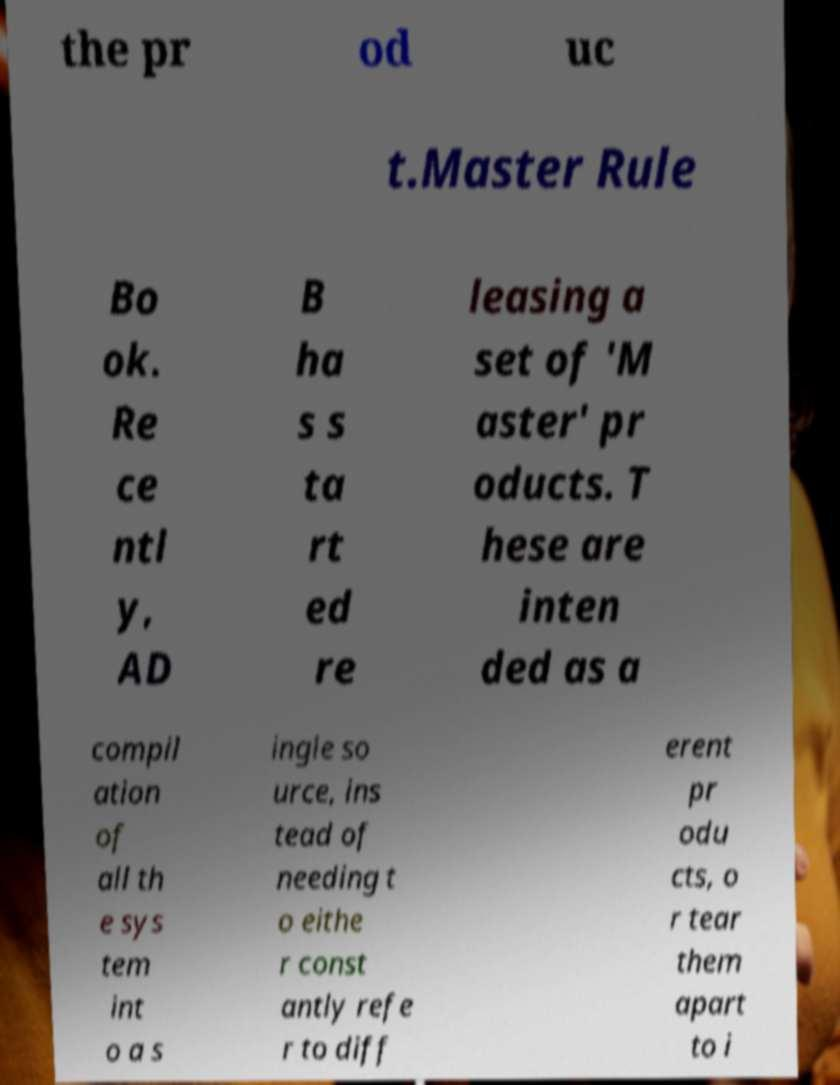Please read and relay the text visible in this image. What does it say? the pr od uc t.Master Rule Bo ok. Re ce ntl y, AD B ha s s ta rt ed re leasing a set of 'M aster' pr oducts. T hese are inten ded as a compil ation of all th e sys tem int o a s ingle so urce, ins tead of needing t o eithe r const antly refe r to diff erent pr odu cts, o r tear them apart to i 